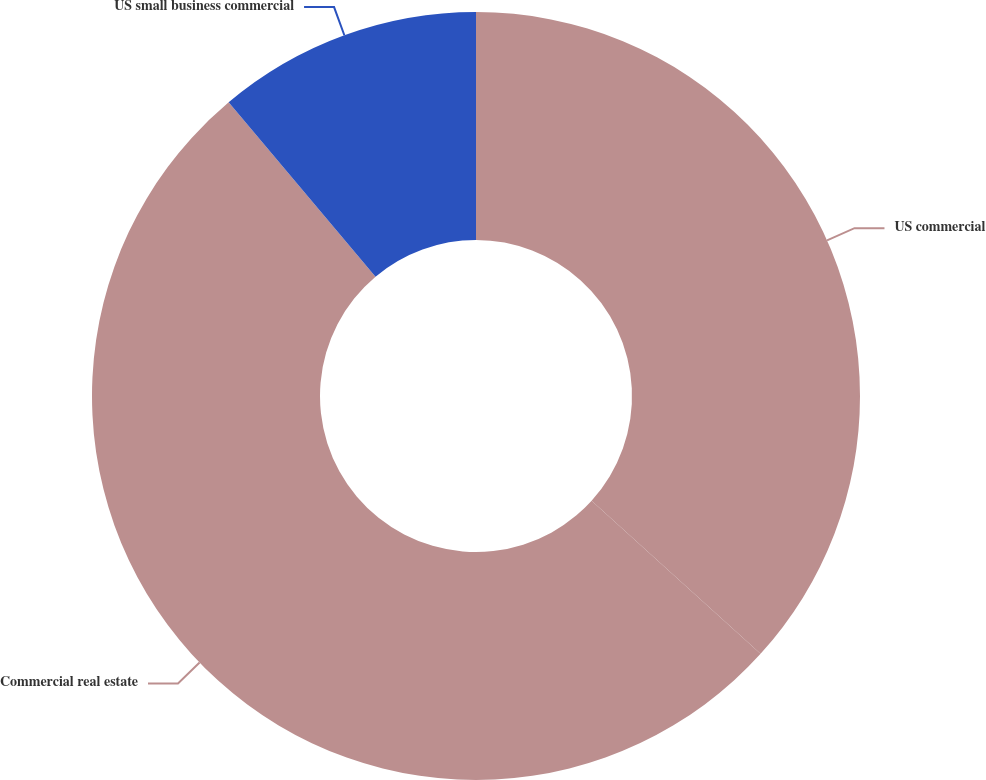Convert chart to OTSL. <chart><loc_0><loc_0><loc_500><loc_500><pie_chart><fcel>US commercial<fcel>Commercial real estate<fcel>US small business commercial<nl><fcel>36.72%<fcel>52.15%<fcel>11.14%<nl></chart> 